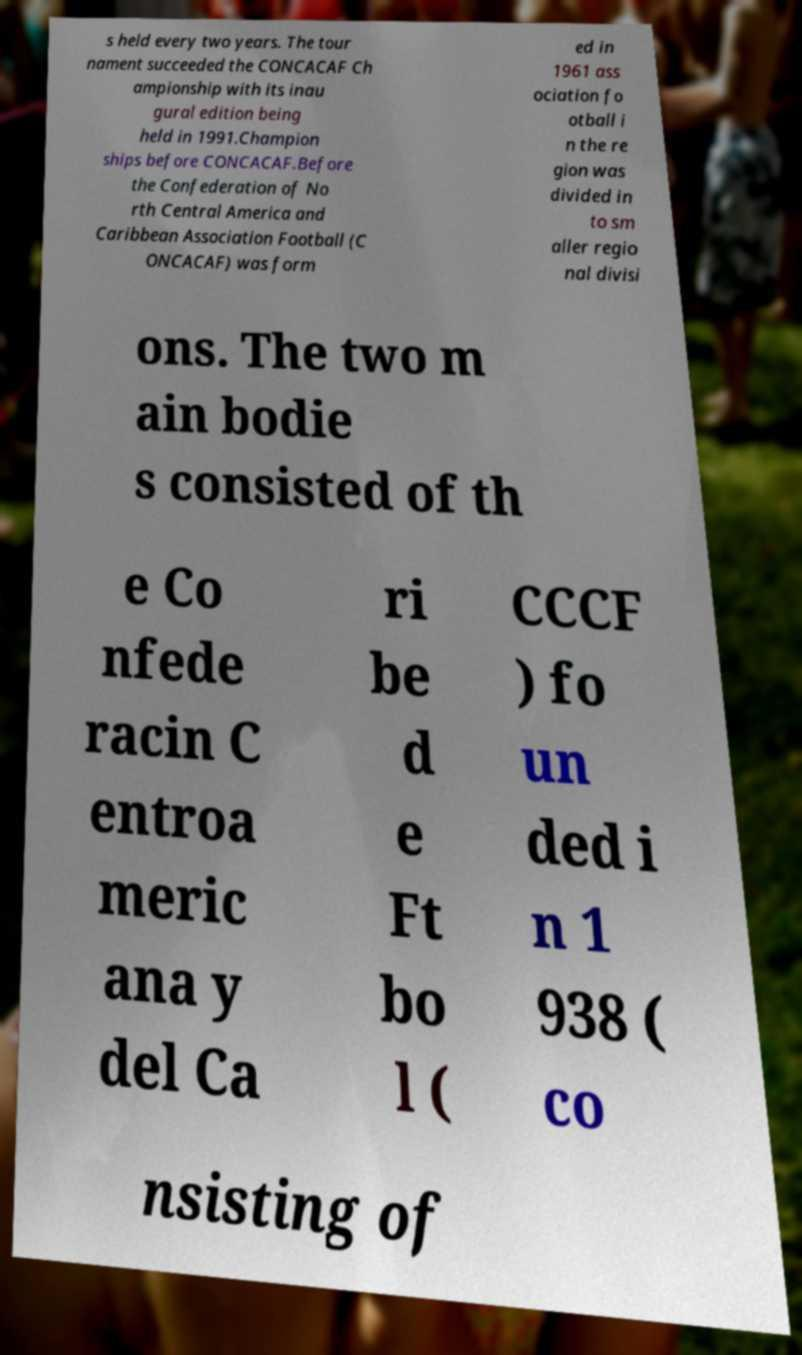Can you read and provide the text displayed in the image?This photo seems to have some interesting text. Can you extract and type it out for me? s held every two years. The tour nament succeeded the CONCACAF Ch ampionship with its inau gural edition being held in 1991.Champion ships before CONCACAF.Before the Confederation of No rth Central America and Caribbean Association Football (C ONCACAF) was form ed in 1961 ass ociation fo otball i n the re gion was divided in to sm aller regio nal divisi ons. The two m ain bodie s consisted of th e Co nfede racin C entroa meric ana y del Ca ri be d e Ft bo l ( CCCF ) fo un ded i n 1 938 ( co nsisting of 